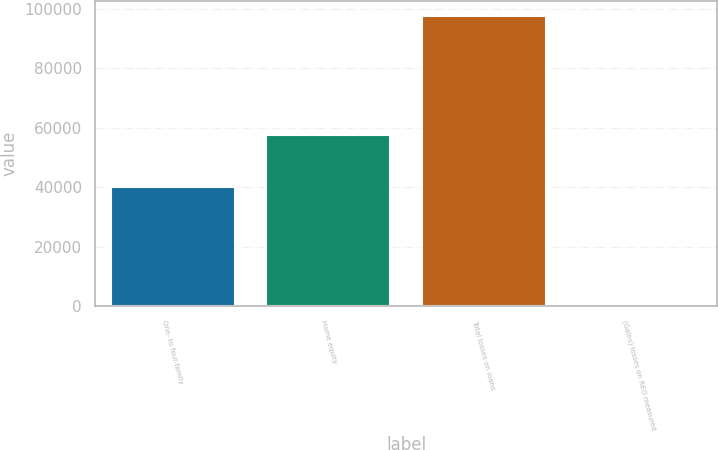<chart> <loc_0><loc_0><loc_500><loc_500><bar_chart><fcel>One- to four-family<fcel>Home equity<fcel>Total losses on loans<fcel>(Gains) losses on REO measured<nl><fcel>40047<fcel>57626<fcel>97673<fcel>565<nl></chart> 